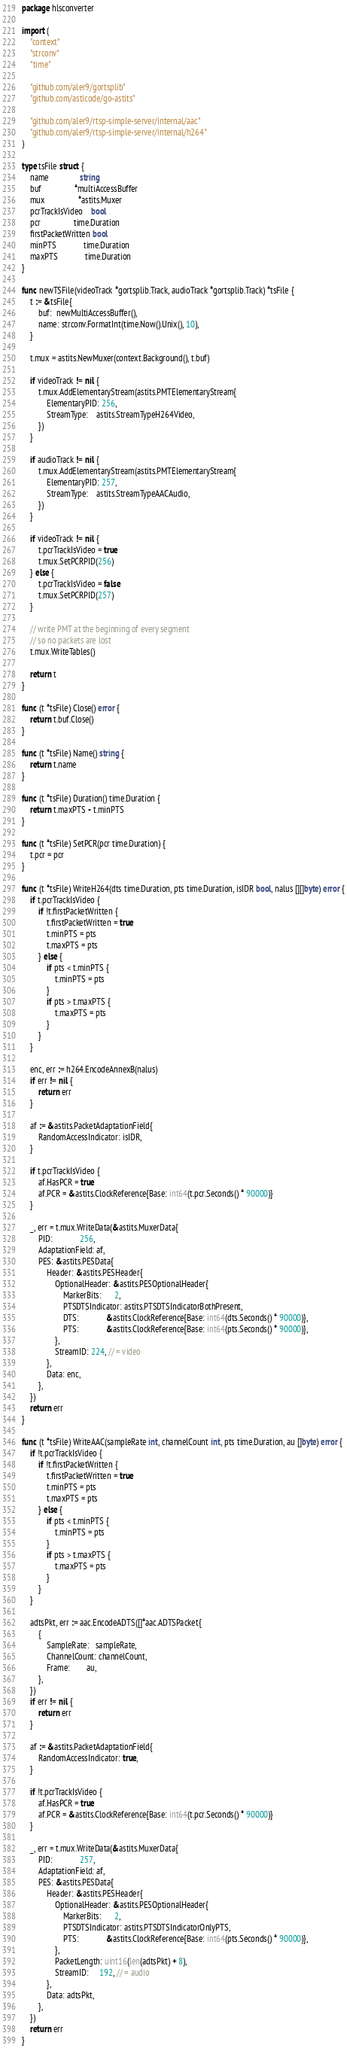<code> <loc_0><loc_0><loc_500><loc_500><_Go_>package hlsconverter

import (
	"context"
	"strconv"
	"time"

	"github.com/aler9/gortsplib"
	"github.com/asticode/go-astits"

	"github.com/aler9/rtsp-simple-server/internal/aac"
	"github.com/aler9/rtsp-simple-server/internal/h264"
)

type tsFile struct {
	name               string
	buf                *multiAccessBuffer
	mux                *astits.Muxer
	pcrTrackIsVideo    bool
	pcr                time.Duration
	firstPacketWritten bool
	minPTS             time.Duration
	maxPTS             time.Duration
}

func newTSFile(videoTrack *gortsplib.Track, audioTrack *gortsplib.Track) *tsFile {
	t := &tsFile{
		buf:  newMultiAccessBuffer(),
		name: strconv.FormatInt(time.Now().Unix(), 10),
	}

	t.mux = astits.NewMuxer(context.Background(), t.buf)

	if videoTrack != nil {
		t.mux.AddElementaryStream(astits.PMTElementaryStream{
			ElementaryPID: 256,
			StreamType:    astits.StreamTypeH264Video,
		})
	}

	if audioTrack != nil {
		t.mux.AddElementaryStream(astits.PMTElementaryStream{
			ElementaryPID: 257,
			StreamType:    astits.StreamTypeAACAudio,
		})
	}

	if videoTrack != nil {
		t.pcrTrackIsVideo = true
		t.mux.SetPCRPID(256)
	} else {
		t.pcrTrackIsVideo = false
		t.mux.SetPCRPID(257)
	}

	// write PMT at the beginning of every segment
	// so no packets are lost
	t.mux.WriteTables()

	return t
}

func (t *tsFile) Close() error {
	return t.buf.Close()
}

func (t *tsFile) Name() string {
	return t.name
}

func (t *tsFile) Duration() time.Duration {
	return t.maxPTS - t.minPTS
}

func (t *tsFile) SetPCR(pcr time.Duration) {
	t.pcr = pcr
}

func (t *tsFile) WriteH264(dts time.Duration, pts time.Duration, isIDR bool, nalus [][]byte) error {
	if t.pcrTrackIsVideo {
		if !t.firstPacketWritten {
			t.firstPacketWritten = true
			t.minPTS = pts
			t.maxPTS = pts
		} else {
			if pts < t.minPTS {
				t.minPTS = pts
			}
			if pts > t.maxPTS {
				t.maxPTS = pts
			}
		}
	}

	enc, err := h264.EncodeAnnexB(nalus)
	if err != nil {
		return err
	}

	af := &astits.PacketAdaptationField{
		RandomAccessIndicator: isIDR,
	}

	if t.pcrTrackIsVideo {
		af.HasPCR = true
		af.PCR = &astits.ClockReference{Base: int64(t.pcr.Seconds() * 90000)}
	}

	_, err = t.mux.WriteData(&astits.MuxerData{
		PID:             256,
		AdaptationField: af,
		PES: &astits.PESData{
			Header: &astits.PESHeader{
				OptionalHeader: &astits.PESOptionalHeader{
					MarkerBits:      2,
					PTSDTSIndicator: astits.PTSDTSIndicatorBothPresent,
					DTS:             &astits.ClockReference{Base: int64(dts.Seconds() * 90000)},
					PTS:             &astits.ClockReference{Base: int64(pts.Seconds() * 90000)},
				},
				StreamID: 224, // = video
			},
			Data: enc,
		},
	})
	return err
}

func (t *tsFile) WriteAAC(sampleRate int, channelCount int, pts time.Duration, au []byte) error {
	if !t.pcrTrackIsVideo {
		if !t.firstPacketWritten {
			t.firstPacketWritten = true
			t.minPTS = pts
			t.maxPTS = pts
		} else {
			if pts < t.minPTS {
				t.minPTS = pts
			}
			if pts > t.maxPTS {
				t.maxPTS = pts
			}
		}
	}

	adtsPkt, err := aac.EncodeADTS([]*aac.ADTSPacket{
		{
			SampleRate:   sampleRate,
			ChannelCount: channelCount,
			Frame:        au,
		},
	})
	if err != nil {
		return err
	}

	af := &astits.PacketAdaptationField{
		RandomAccessIndicator: true,
	}

	if !t.pcrTrackIsVideo {
		af.HasPCR = true
		af.PCR = &astits.ClockReference{Base: int64(t.pcr.Seconds() * 90000)}
	}

	_, err = t.mux.WriteData(&astits.MuxerData{
		PID:             257,
		AdaptationField: af,
		PES: &astits.PESData{
			Header: &astits.PESHeader{
				OptionalHeader: &astits.PESOptionalHeader{
					MarkerBits:      2,
					PTSDTSIndicator: astits.PTSDTSIndicatorOnlyPTS,
					PTS:             &astits.ClockReference{Base: int64(pts.Seconds() * 90000)},
				},
				PacketLength: uint16(len(adtsPkt) + 8),
				StreamID:     192, // = audio
			},
			Data: adtsPkt,
		},
	})
	return err
}
</code> 